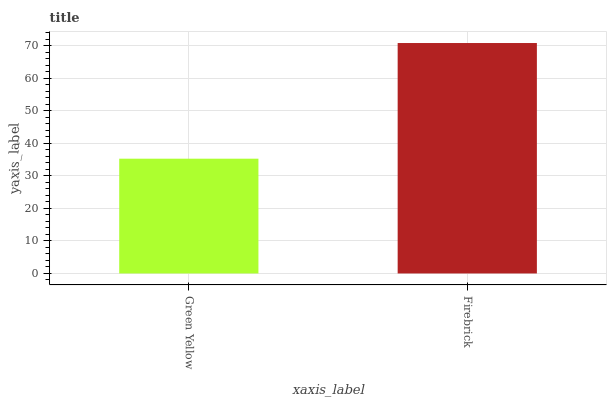Is Green Yellow the minimum?
Answer yes or no. Yes. Is Firebrick the maximum?
Answer yes or no. Yes. Is Firebrick the minimum?
Answer yes or no. No. Is Firebrick greater than Green Yellow?
Answer yes or no. Yes. Is Green Yellow less than Firebrick?
Answer yes or no. Yes. Is Green Yellow greater than Firebrick?
Answer yes or no. No. Is Firebrick less than Green Yellow?
Answer yes or no. No. Is Firebrick the high median?
Answer yes or no. Yes. Is Green Yellow the low median?
Answer yes or no. Yes. Is Green Yellow the high median?
Answer yes or no. No. Is Firebrick the low median?
Answer yes or no. No. 